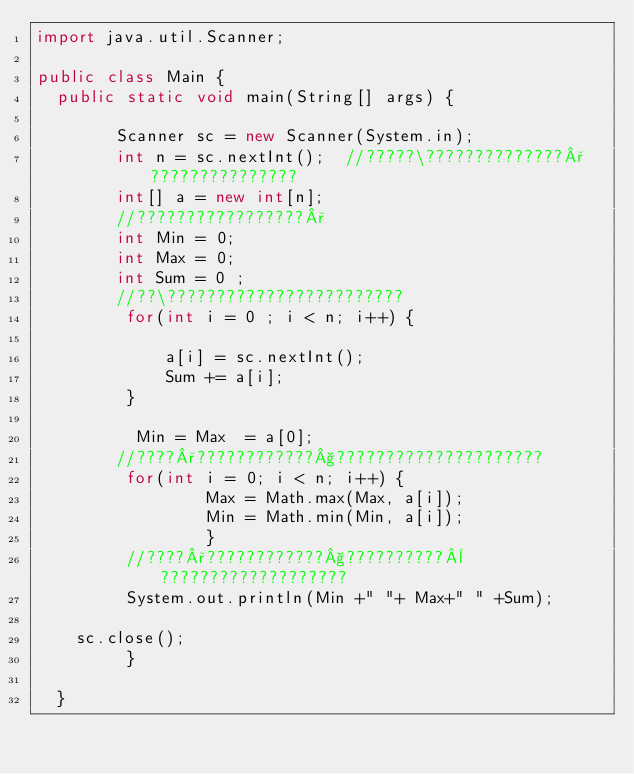Convert code to text. <code><loc_0><loc_0><loc_500><loc_500><_Java_>import java.util.Scanner;

public class Main {
  public static void main(String[] args) {
		
		Scanner sc = new Scanner(System.in);
		int n = sc.nextInt();  //?????\??????????????°???????????????
		int[] a = new int[n];
		//?????????????????°
		int Min = 0;
		int Max = 0;
		int Sum = 0 ;
		//??\????????????????????????
		 for(int i = 0 ; i < n; i++) {
			 
			 a[i] = sc.nextInt();
			 Sum += a[i];
		 }
		 
		  Min = Max  = a[0];
		//????°????????????§????????????????????? 
		 for(int i = 0; i < n; i++) {
				 Max = Math.max(Max, a[i]);
				 Min = Math.min(Min, a[i]);
				 }
		 //????°????????????§??????????¨???????????????????
		 System.out.println(Min +" "+ Max+" " +Sum);
			 
	sc.close();
		 }

  }</code> 